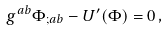<formula> <loc_0><loc_0><loc_500><loc_500>g ^ { a b } \Phi _ { ; a b } - U ^ { \prime } ( \Phi ) = 0 \, ,</formula> 